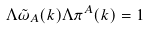<formula> <loc_0><loc_0><loc_500><loc_500>\Lambda \tilde { \omega } _ { A } ( { k } ) \Lambda \pi ^ { A } ( { k } ) = 1</formula> 